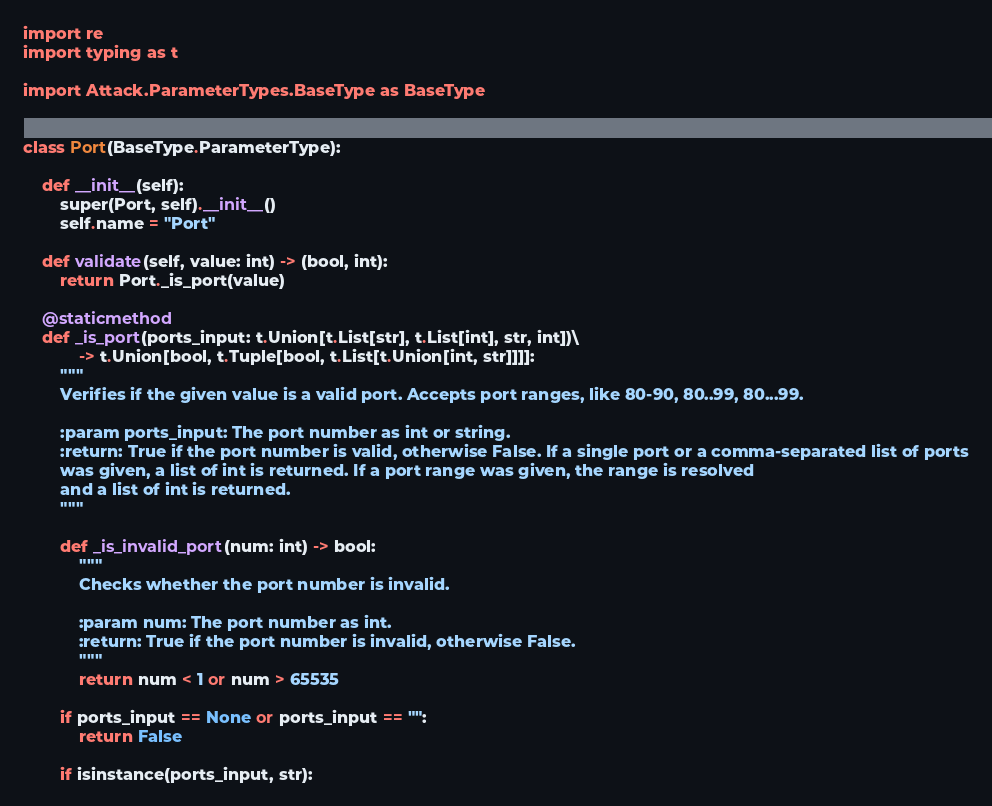<code> <loc_0><loc_0><loc_500><loc_500><_Python_>import re
import typing as t

import Attack.ParameterTypes.BaseType as BaseType


class Port(BaseType.ParameterType):

    def __init__(self):
        super(Port, self).__init__()
        self.name = "Port"

    def validate(self, value: int) -> (bool, int):
        return Port._is_port(value)

    @staticmethod
    def _is_port(ports_input: t.Union[t.List[str], t.List[int], str, int])\
            -> t.Union[bool, t.Tuple[bool, t.List[t.Union[int, str]]]]:
        """
        Verifies if the given value is a valid port. Accepts port ranges, like 80-90, 80..99, 80...99.

        :param ports_input: The port number as int or string.
        :return: True if the port number is valid, otherwise False. If a single port or a comma-separated list of ports
        was given, a list of int is returned. If a port range was given, the range is resolved
        and a list of int is returned.
        """

        def _is_invalid_port(num: int) -> bool:
            """
            Checks whether the port number is invalid.

            :param num: The port number as int.
            :return: True if the port number is invalid, otherwise False.
            """
            return num < 1 or num > 65535

        if ports_input == None or ports_input == "":
            return False

        if isinstance(ports_input, str):</code> 